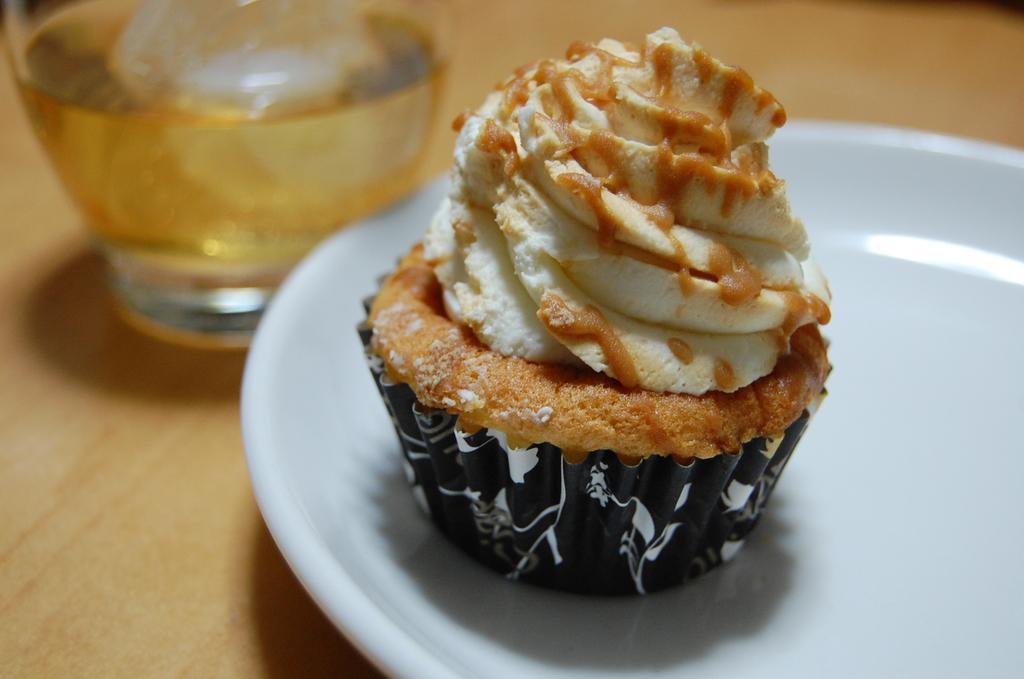How would you summarize this image in a sentence or two? Here I can see a plate which consists of cupcake. This plate is placed on a table. Beside the plate there is a glass which consists of drink. 